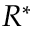Convert formula to latex. <formula><loc_0><loc_0><loc_500><loc_500>R ^ { * }</formula> 